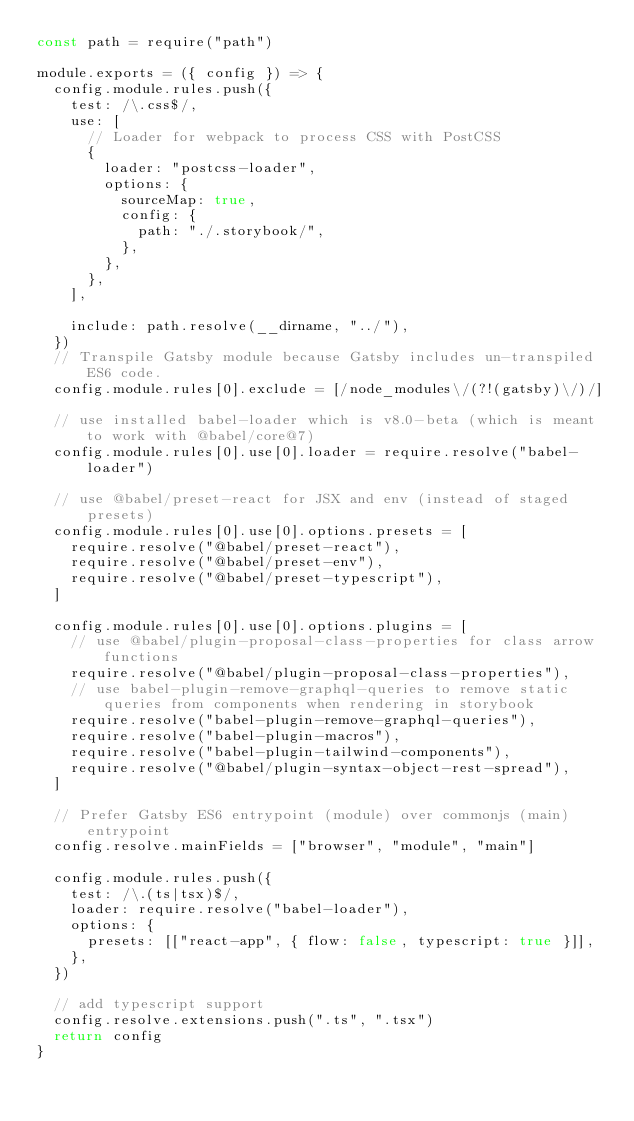Convert code to text. <code><loc_0><loc_0><loc_500><loc_500><_JavaScript_>const path = require("path")

module.exports = ({ config }) => {
  config.module.rules.push({
    test: /\.css$/,
    use: [
      // Loader for webpack to process CSS with PostCSS
      {
        loader: "postcss-loader",
        options: {
          sourceMap: true,
          config: {
            path: "./.storybook/",
          },
        },
      },
    ],

    include: path.resolve(__dirname, "../"),
  })
  // Transpile Gatsby module because Gatsby includes un-transpiled ES6 code.
  config.module.rules[0].exclude = [/node_modules\/(?!(gatsby)\/)/]

  // use installed babel-loader which is v8.0-beta (which is meant to work with @babel/core@7)
  config.module.rules[0].use[0].loader = require.resolve("babel-loader")

  // use @babel/preset-react for JSX and env (instead of staged presets)
  config.module.rules[0].use[0].options.presets = [
    require.resolve("@babel/preset-react"),
    require.resolve("@babel/preset-env"),
    require.resolve("@babel/preset-typescript"),
  ]

  config.module.rules[0].use[0].options.plugins = [
    // use @babel/plugin-proposal-class-properties for class arrow functions
    require.resolve("@babel/plugin-proposal-class-properties"),
    // use babel-plugin-remove-graphql-queries to remove static queries from components when rendering in storybook
    require.resolve("babel-plugin-remove-graphql-queries"),
    require.resolve("babel-plugin-macros"),
    require.resolve("babel-plugin-tailwind-components"),
    require.resolve("@babel/plugin-syntax-object-rest-spread"),
  ]

  // Prefer Gatsby ES6 entrypoint (module) over commonjs (main) entrypoint
  config.resolve.mainFields = ["browser", "module", "main"]

  config.module.rules.push({
    test: /\.(ts|tsx)$/,
    loader: require.resolve("babel-loader"),
    options: {
      presets: [["react-app", { flow: false, typescript: true }]],
    },
  })

  // add typescript support
  config.resolve.extensions.push(".ts", ".tsx")
  return config
}
</code> 